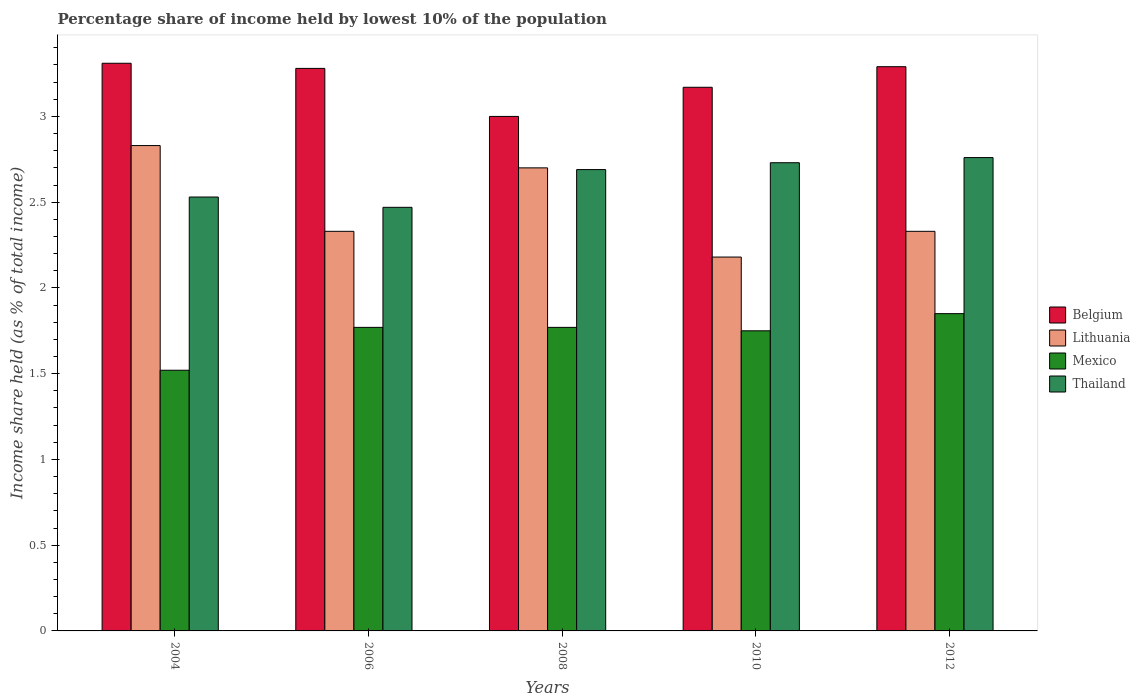Are the number of bars per tick equal to the number of legend labels?
Offer a terse response. Yes. How many bars are there on the 1st tick from the right?
Offer a very short reply. 4. What is the percentage share of income held by lowest 10% of the population in Mexico in 2004?
Ensure brevity in your answer.  1.52. Across all years, what is the maximum percentage share of income held by lowest 10% of the population in Lithuania?
Your response must be concise. 2.83. Across all years, what is the minimum percentage share of income held by lowest 10% of the population in Belgium?
Your response must be concise. 3. In which year was the percentage share of income held by lowest 10% of the population in Mexico maximum?
Make the answer very short. 2012. In which year was the percentage share of income held by lowest 10% of the population in Thailand minimum?
Make the answer very short. 2006. What is the total percentage share of income held by lowest 10% of the population in Belgium in the graph?
Your answer should be compact. 16.05. What is the difference between the percentage share of income held by lowest 10% of the population in Lithuania in 2010 and the percentage share of income held by lowest 10% of the population in Mexico in 2004?
Make the answer very short. 0.66. What is the average percentage share of income held by lowest 10% of the population in Belgium per year?
Keep it short and to the point. 3.21. In the year 2008, what is the difference between the percentage share of income held by lowest 10% of the population in Mexico and percentage share of income held by lowest 10% of the population in Lithuania?
Provide a succinct answer. -0.93. What is the ratio of the percentage share of income held by lowest 10% of the population in Mexico in 2004 to that in 2010?
Keep it short and to the point. 0.87. Is the percentage share of income held by lowest 10% of the population in Thailand in 2008 less than that in 2012?
Offer a very short reply. Yes. Is the difference between the percentage share of income held by lowest 10% of the population in Mexico in 2010 and 2012 greater than the difference between the percentage share of income held by lowest 10% of the population in Lithuania in 2010 and 2012?
Make the answer very short. Yes. What is the difference between the highest and the second highest percentage share of income held by lowest 10% of the population in Lithuania?
Provide a short and direct response. 0.13. What is the difference between the highest and the lowest percentage share of income held by lowest 10% of the population in Lithuania?
Make the answer very short. 0.65. What does the 4th bar from the left in 2006 represents?
Give a very brief answer. Thailand. What does the 1st bar from the right in 2012 represents?
Provide a succinct answer. Thailand. How many bars are there?
Offer a very short reply. 20. What is the difference between two consecutive major ticks on the Y-axis?
Provide a succinct answer. 0.5. Does the graph contain grids?
Keep it short and to the point. No. How many legend labels are there?
Offer a very short reply. 4. How are the legend labels stacked?
Give a very brief answer. Vertical. What is the title of the graph?
Give a very brief answer. Percentage share of income held by lowest 10% of the population. Does "Afghanistan" appear as one of the legend labels in the graph?
Your answer should be very brief. No. What is the label or title of the Y-axis?
Give a very brief answer. Income share held (as % of total income). What is the Income share held (as % of total income) of Belgium in 2004?
Ensure brevity in your answer.  3.31. What is the Income share held (as % of total income) in Lithuania in 2004?
Offer a very short reply. 2.83. What is the Income share held (as % of total income) in Mexico in 2004?
Ensure brevity in your answer.  1.52. What is the Income share held (as % of total income) of Thailand in 2004?
Ensure brevity in your answer.  2.53. What is the Income share held (as % of total income) in Belgium in 2006?
Provide a short and direct response. 3.28. What is the Income share held (as % of total income) of Lithuania in 2006?
Offer a very short reply. 2.33. What is the Income share held (as % of total income) of Mexico in 2006?
Offer a terse response. 1.77. What is the Income share held (as % of total income) in Thailand in 2006?
Provide a succinct answer. 2.47. What is the Income share held (as % of total income) of Mexico in 2008?
Offer a terse response. 1.77. What is the Income share held (as % of total income) in Thailand in 2008?
Provide a short and direct response. 2.69. What is the Income share held (as % of total income) of Belgium in 2010?
Provide a short and direct response. 3.17. What is the Income share held (as % of total income) of Lithuania in 2010?
Provide a short and direct response. 2.18. What is the Income share held (as % of total income) of Thailand in 2010?
Offer a very short reply. 2.73. What is the Income share held (as % of total income) of Belgium in 2012?
Offer a terse response. 3.29. What is the Income share held (as % of total income) of Lithuania in 2012?
Your answer should be very brief. 2.33. What is the Income share held (as % of total income) in Mexico in 2012?
Your answer should be compact. 1.85. What is the Income share held (as % of total income) in Thailand in 2012?
Offer a terse response. 2.76. Across all years, what is the maximum Income share held (as % of total income) in Belgium?
Ensure brevity in your answer.  3.31. Across all years, what is the maximum Income share held (as % of total income) of Lithuania?
Your response must be concise. 2.83. Across all years, what is the maximum Income share held (as % of total income) in Mexico?
Give a very brief answer. 1.85. Across all years, what is the maximum Income share held (as % of total income) in Thailand?
Your answer should be compact. 2.76. Across all years, what is the minimum Income share held (as % of total income) of Belgium?
Offer a very short reply. 3. Across all years, what is the minimum Income share held (as % of total income) of Lithuania?
Provide a short and direct response. 2.18. Across all years, what is the minimum Income share held (as % of total income) in Mexico?
Ensure brevity in your answer.  1.52. Across all years, what is the minimum Income share held (as % of total income) in Thailand?
Keep it short and to the point. 2.47. What is the total Income share held (as % of total income) in Belgium in the graph?
Keep it short and to the point. 16.05. What is the total Income share held (as % of total income) in Lithuania in the graph?
Make the answer very short. 12.37. What is the total Income share held (as % of total income) in Mexico in the graph?
Your answer should be very brief. 8.66. What is the total Income share held (as % of total income) in Thailand in the graph?
Provide a succinct answer. 13.18. What is the difference between the Income share held (as % of total income) of Lithuania in 2004 and that in 2006?
Give a very brief answer. 0.5. What is the difference between the Income share held (as % of total income) of Mexico in 2004 and that in 2006?
Give a very brief answer. -0.25. What is the difference between the Income share held (as % of total income) of Thailand in 2004 and that in 2006?
Provide a short and direct response. 0.06. What is the difference between the Income share held (as % of total income) in Belgium in 2004 and that in 2008?
Your answer should be compact. 0.31. What is the difference between the Income share held (as % of total income) in Lithuania in 2004 and that in 2008?
Keep it short and to the point. 0.13. What is the difference between the Income share held (as % of total income) in Mexico in 2004 and that in 2008?
Provide a short and direct response. -0.25. What is the difference between the Income share held (as % of total income) in Thailand in 2004 and that in 2008?
Offer a very short reply. -0.16. What is the difference between the Income share held (as % of total income) of Belgium in 2004 and that in 2010?
Your answer should be compact. 0.14. What is the difference between the Income share held (as % of total income) in Lithuania in 2004 and that in 2010?
Your answer should be compact. 0.65. What is the difference between the Income share held (as % of total income) in Mexico in 2004 and that in 2010?
Provide a succinct answer. -0.23. What is the difference between the Income share held (as % of total income) in Thailand in 2004 and that in 2010?
Your response must be concise. -0.2. What is the difference between the Income share held (as % of total income) of Lithuania in 2004 and that in 2012?
Your response must be concise. 0.5. What is the difference between the Income share held (as % of total income) of Mexico in 2004 and that in 2012?
Offer a terse response. -0.33. What is the difference between the Income share held (as % of total income) of Thailand in 2004 and that in 2012?
Offer a terse response. -0.23. What is the difference between the Income share held (as % of total income) of Belgium in 2006 and that in 2008?
Offer a very short reply. 0.28. What is the difference between the Income share held (as % of total income) of Lithuania in 2006 and that in 2008?
Your answer should be very brief. -0.37. What is the difference between the Income share held (as % of total income) in Thailand in 2006 and that in 2008?
Provide a succinct answer. -0.22. What is the difference between the Income share held (as % of total income) in Belgium in 2006 and that in 2010?
Offer a very short reply. 0.11. What is the difference between the Income share held (as % of total income) in Thailand in 2006 and that in 2010?
Offer a very short reply. -0.26. What is the difference between the Income share held (as % of total income) in Belgium in 2006 and that in 2012?
Ensure brevity in your answer.  -0.01. What is the difference between the Income share held (as % of total income) of Lithuania in 2006 and that in 2012?
Offer a very short reply. 0. What is the difference between the Income share held (as % of total income) in Mexico in 2006 and that in 2012?
Ensure brevity in your answer.  -0.08. What is the difference between the Income share held (as % of total income) in Thailand in 2006 and that in 2012?
Your response must be concise. -0.29. What is the difference between the Income share held (as % of total income) of Belgium in 2008 and that in 2010?
Your answer should be compact. -0.17. What is the difference between the Income share held (as % of total income) of Lithuania in 2008 and that in 2010?
Your answer should be compact. 0.52. What is the difference between the Income share held (as % of total income) in Thailand in 2008 and that in 2010?
Your answer should be very brief. -0.04. What is the difference between the Income share held (as % of total income) in Belgium in 2008 and that in 2012?
Ensure brevity in your answer.  -0.29. What is the difference between the Income share held (as % of total income) in Lithuania in 2008 and that in 2012?
Provide a short and direct response. 0.37. What is the difference between the Income share held (as % of total income) in Mexico in 2008 and that in 2012?
Your response must be concise. -0.08. What is the difference between the Income share held (as % of total income) of Thailand in 2008 and that in 2012?
Provide a succinct answer. -0.07. What is the difference between the Income share held (as % of total income) in Belgium in 2010 and that in 2012?
Your answer should be compact. -0.12. What is the difference between the Income share held (as % of total income) in Mexico in 2010 and that in 2012?
Offer a terse response. -0.1. What is the difference between the Income share held (as % of total income) in Thailand in 2010 and that in 2012?
Make the answer very short. -0.03. What is the difference between the Income share held (as % of total income) in Belgium in 2004 and the Income share held (as % of total income) in Mexico in 2006?
Provide a succinct answer. 1.54. What is the difference between the Income share held (as % of total income) of Belgium in 2004 and the Income share held (as % of total income) of Thailand in 2006?
Your answer should be compact. 0.84. What is the difference between the Income share held (as % of total income) of Lithuania in 2004 and the Income share held (as % of total income) of Mexico in 2006?
Ensure brevity in your answer.  1.06. What is the difference between the Income share held (as % of total income) in Lithuania in 2004 and the Income share held (as % of total income) in Thailand in 2006?
Keep it short and to the point. 0.36. What is the difference between the Income share held (as % of total income) in Mexico in 2004 and the Income share held (as % of total income) in Thailand in 2006?
Make the answer very short. -0.95. What is the difference between the Income share held (as % of total income) in Belgium in 2004 and the Income share held (as % of total income) in Lithuania in 2008?
Provide a succinct answer. 0.61. What is the difference between the Income share held (as % of total income) of Belgium in 2004 and the Income share held (as % of total income) of Mexico in 2008?
Offer a terse response. 1.54. What is the difference between the Income share held (as % of total income) in Belgium in 2004 and the Income share held (as % of total income) in Thailand in 2008?
Make the answer very short. 0.62. What is the difference between the Income share held (as % of total income) of Lithuania in 2004 and the Income share held (as % of total income) of Mexico in 2008?
Your response must be concise. 1.06. What is the difference between the Income share held (as % of total income) of Lithuania in 2004 and the Income share held (as % of total income) of Thailand in 2008?
Provide a short and direct response. 0.14. What is the difference between the Income share held (as % of total income) in Mexico in 2004 and the Income share held (as % of total income) in Thailand in 2008?
Your answer should be very brief. -1.17. What is the difference between the Income share held (as % of total income) in Belgium in 2004 and the Income share held (as % of total income) in Lithuania in 2010?
Keep it short and to the point. 1.13. What is the difference between the Income share held (as % of total income) of Belgium in 2004 and the Income share held (as % of total income) of Mexico in 2010?
Provide a succinct answer. 1.56. What is the difference between the Income share held (as % of total income) of Belgium in 2004 and the Income share held (as % of total income) of Thailand in 2010?
Offer a very short reply. 0.58. What is the difference between the Income share held (as % of total income) of Lithuania in 2004 and the Income share held (as % of total income) of Thailand in 2010?
Give a very brief answer. 0.1. What is the difference between the Income share held (as % of total income) of Mexico in 2004 and the Income share held (as % of total income) of Thailand in 2010?
Your answer should be very brief. -1.21. What is the difference between the Income share held (as % of total income) in Belgium in 2004 and the Income share held (as % of total income) in Lithuania in 2012?
Keep it short and to the point. 0.98. What is the difference between the Income share held (as % of total income) in Belgium in 2004 and the Income share held (as % of total income) in Mexico in 2012?
Make the answer very short. 1.46. What is the difference between the Income share held (as % of total income) in Belgium in 2004 and the Income share held (as % of total income) in Thailand in 2012?
Your response must be concise. 0.55. What is the difference between the Income share held (as % of total income) of Lithuania in 2004 and the Income share held (as % of total income) of Thailand in 2012?
Offer a very short reply. 0.07. What is the difference between the Income share held (as % of total income) in Mexico in 2004 and the Income share held (as % of total income) in Thailand in 2012?
Ensure brevity in your answer.  -1.24. What is the difference between the Income share held (as % of total income) of Belgium in 2006 and the Income share held (as % of total income) of Lithuania in 2008?
Provide a succinct answer. 0.58. What is the difference between the Income share held (as % of total income) of Belgium in 2006 and the Income share held (as % of total income) of Mexico in 2008?
Provide a succinct answer. 1.51. What is the difference between the Income share held (as % of total income) of Belgium in 2006 and the Income share held (as % of total income) of Thailand in 2008?
Ensure brevity in your answer.  0.59. What is the difference between the Income share held (as % of total income) of Lithuania in 2006 and the Income share held (as % of total income) of Mexico in 2008?
Offer a very short reply. 0.56. What is the difference between the Income share held (as % of total income) of Lithuania in 2006 and the Income share held (as % of total income) of Thailand in 2008?
Ensure brevity in your answer.  -0.36. What is the difference between the Income share held (as % of total income) in Mexico in 2006 and the Income share held (as % of total income) in Thailand in 2008?
Your answer should be very brief. -0.92. What is the difference between the Income share held (as % of total income) in Belgium in 2006 and the Income share held (as % of total income) in Lithuania in 2010?
Give a very brief answer. 1.1. What is the difference between the Income share held (as % of total income) of Belgium in 2006 and the Income share held (as % of total income) of Mexico in 2010?
Your answer should be very brief. 1.53. What is the difference between the Income share held (as % of total income) of Belgium in 2006 and the Income share held (as % of total income) of Thailand in 2010?
Provide a succinct answer. 0.55. What is the difference between the Income share held (as % of total income) in Lithuania in 2006 and the Income share held (as % of total income) in Mexico in 2010?
Offer a very short reply. 0.58. What is the difference between the Income share held (as % of total income) of Lithuania in 2006 and the Income share held (as % of total income) of Thailand in 2010?
Keep it short and to the point. -0.4. What is the difference between the Income share held (as % of total income) in Mexico in 2006 and the Income share held (as % of total income) in Thailand in 2010?
Keep it short and to the point. -0.96. What is the difference between the Income share held (as % of total income) in Belgium in 2006 and the Income share held (as % of total income) in Lithuania in 2012?
Offer a terse response. 0.95. What is the difference between the Income share held (as % of total income) of Belgium in 2006 and the Income share held (as % of total income) of Mexico in 2012?
Keep it short and to the point. 1.43. What is the difference between the Income share held (as % of total income) of Belgium in 2006 and the Income share held (as % of total income) of Thailand in 2012?
Your response must be concise. 0.52. What is the difference between the Income share held (as % of total income) in Lithuania in 2006 and the Income share held (as % of total income) in Mexico in 2012?
Provide a succinct answer. 0.48. What is the difference between the Income share held (as % of total income) of Lithuania in 2006 and the Income share held (as % of total income) of Thailand in 2012?
Provide a succinct answer. -0.43. What is the difference between the Income share held (as % of total income) of Mexico in 2006 and the Income share held (as % of total income) of Thailand in 2012?
Offer a very short reply. -0.99. What is the difference between the Income share held (as % of total income) in Belgium in 2008 and the Income share held (as % of total income) in Lithuania in 2010?
Offer a terse response. 0.82. What is the difference between the Income share held (as % of total income) in Belgium in 2008 and the Income share held (as % of total income) in Thailand in 2010?
Your answer should be very brief. 0.27. What is the difference between the Income share held (as % of total income) of Lithuania in 2008 and the Income share held (as % of total income) of Thailand in 2010?
Your answer should be very brief. -0.03. What is the difference between the Income share held (as % of total income) of Mexico in 2008 and the Income share held (as % of total income) of Thailand in 2010?
Make the answer very short. -0.96. What is the difference between the Income share held (as % of total income) in Belgium in 2008 and the Income share held (as % of total income) in Lithuania in 2012?
Ensure brevity in your answer.  0.67. What is the difference between the Income share held (as % of total income) of Belgium in 2008 and the Income share held (as % of total income) of Mexico in 2012?
Make the answer very short. 1.15. What is the difference between the Income share held (as % of total income) in Belgium in 2008 and the Income share held (as % of total income) in Thailand in 2012?
Your answer should be compact. 0.24. What is the difference between the Income share held (as % of total income) of Lithuania in 2008 and the Income share held (as % of total income) of Thailand in 2012?
Your answer should be compact. -0.06. What is the difference between the Income share held (as % of total income) in Mexico in 2008 and the Income share held (as % of total income) in Thailand in 2012?
Ensure brevity in your answer.  -0.99. What is the difference between the Income share held (as % of total income) in Belgium in 2010 and the Income share held (as % of total income) in Lithuania in 2012?
Offer a very short reply. 0.84. What is the difference between the Income share held (as % of total income) in Belgium in 2010 and the Income share held (as % of total income) in Mexico in 2012?
Ensure brevity in your answer.  1.32. What is the difference between the Income share held (as % of total income) in Belgium in 2010 and the Income share held (as % of total income) in Thailand in 2012?
Keep it short and to the point. 0.41. What is the difference between the Income share held (as % of total income) of Lithuania in 2010 and the Income share held (as % of total income) of Mexico in 2012?
Offer a terse response. 0.33. What is the difference between the Income share held (as % of total income) in Lithuania in 2010 and the Income share held (as % of total income) in Thailand in 2012?
Offer a very short reply. -0.58. What is the difference between the Income share held (as % of total income) in Mexico in 2010 and the Income share held (as % of total income) in Thailand in 2012?
Offer a terse response. -1.01. What is the average Income share held (as % of total income) of Belgium per year?
Ensure brevity in your answer.  3.21. What is the average Income share held (as % of total income) in Lithuania per year?
Your response must be concise. 2.47. What is the average Income share held (as % of total income) in Mexico per year?
Your response must be concise. 1.73. What is the average Income share held (as % of total income) in Thailand per year?
Your answer should be very brief. 2.64. In the year 2004, what is the difference between the Income share held (as % of total income) of Belgium and Income share held (as % of total income) of Lithuania?
Your response must be concise. 0.48. In the year 2004, what is the difference between the Income share held (as % of total income) of Belgium and Income share held (as % of total income) of Mexico?
Your response must be concise. 1.79. In the year 2004, what is the difference between the Income share held (as % of total income) of Belgium and Income share held (as % of total income) of Thailand?
Offer a terse response. 0.78. In the year 2004, what is the difference between the Income share held (as % of total income) in Lithuania and Income share held (as % of total income) in Mexico?
Provide a short and direct response. 1.31. In the year 2004, what is the difference between the Income share held (as % of total income) of Lithuania and Income share held (as % of total income) of Thailand?
Your response must be concise. 0.3. In the year 2004, what is the difference between the Income share held (as % of total income) in Mexico and Income share held (as % of total income) in Thailand?
Provide a short and direct response. -1.01. In the year 2006, what is the difference between the Income share held (as % of total income) in Belgium and Income share held (as % of total income) in Mexico?
Make the answer very short. 1.51. In the year 2006, what is the difference between the Income share held (as % of total income) in Belgium and Income share held (as % of total income) in Thailand?
Give a very brief answer. 0.81. In the year 2006, what is the difference between the Income share held (as % of total income) of Lithuania and Income share held (as % of total income) of Mexico?
Ensure brevity in your answer.  0.56. In the year 2006, what is the difference between the Income share held (as % of total income) of Lithuania and Income share held (as % of total income) of Thailand?
Provide a succinct answer. -0.14. In the year 2008, what is the difference between the Income share held (as % of total income) in Belgium and Income share held (as % of total income) in Lithuania?
Ensure brevity in your answer.  0.3. In the year 2008, what is the difference between the Income share held (as % of total income) of Belgium and Income share held (as % of total income) of Mexico?
Make the answer very short. 1.23. In the year 2008, what is the difference between the Income share held (as % of total income) in Belgium and Income share held (as % of total income) in Thailand?
Offer a terse response. 0.31. In the year 2008, what is the difference between the Income share held (as % of total income) of Lithuania and Income share held (as % of total income) of Thailand?
Your answer should be very brief. 0.01. In the year 2008, what is the difference between the Income share held (as % of total income) of Mexico and Income share held (as % of total income) of Thailand?
Your response must be concise. -0.92. In the year 2010, what is the difference between the Income share held (as % of total income) of Belgium and Income share held (as % of total income) of Mexico?
Give a very brief answer. 1.42. In the year 2010, what is the difference between the Income share held (as % of total income) of Belgium and Income share held (as % of total income) of Thailand?
Make the answer very short. 0.44. In the year 2010, what is the difference between the Income share held (as % of total income) in Lithuania and Income share held (as % of total income) in Mexico?
Your answer should be very brief. 0.43. In the year 2010, what is the difference between the Income share held (as % of total income) of Lithuania and Income share held (as % of total income) of Thailand?
Ensure brevity in your answer.  -0.55. In the year 2010, what is the difference between the Income share held (as % of total income) in Mexico and Income share held (as % of total income) in Thailand?
Ensure brevity in your answer.  -0.98. In the year 2012, what is the difference between the Income share held (as % of total income) of Belgium and Income share held (as % of total income) of Mexico?
Make the answer very short. 1.44. In the year 2012, what is the difference between the Income share held (as % of total income) of Belgium and Income share held (as % of total income) of Thailand?
Make the answer very short. 0.53. In the year 2012, what is the difference between the Income share held (as % of total income) in Lithuania and Income share held (as % of total income) in Mexico?
Your answer should be compact. 0.48. In the year 2012, what is the difference between the Income share held (as % of total income) of Lithuania and Income share held (as % of total income) of Thailand?
Offer a very short reply. -0.43. In the year 2012, what is the difference between the Income share held (as % of total income) in Mexico and Income share held (as % of total income) in Thailand?
Offer a terse response. -0.91. What is the ratio of the Income share held (as % of total income) of Belgium in 2004 to that in 2006?
Your answer should be very brief. 1.01. What is the ratio of the Income share held (as % of total income) of Lithuania in 2004 to that in 2006?
Make the answer very short. 1.21. What is the ratio of the Income share held (as % of total income) of Mexico in 2004 to that in 2006?
Keep it short and to the point. 0.86. What is the ratio of the Income share held (as % of total income) of Thailand in 2004 to that in 2006?
Give a very brief answer. 1.02. What is the ratio of the Income share held (as % of total income) in Belgium in 2004 to that in 2008?
Your response must be concise. 1.1. What is the ratio of the Income share held (as % of total income) of Lithuania in 2004 to that in 2008?
Offer a very short reply. 1.05. What is the ratio of the Income share held (as % of total income) in Mexico in 2004 to that in 2008?
Your answer should be compact. 0.86. What is the ratio of the Income share held (as % of total income) in Thailand in 2004 to that in 2008?
Keep it short and to the point. 0.94. What is the ratio of the Income share held (as % of total income) in Belgium in 2004 to that in 2010?
Your answer should be very brief. 1.04. What is the ratio of the Income share held (as % of total income) of Lithuania in 2004 to that in 2010?
Offer a terse response. 1.3. What is the ratio of the Income share held (as % of total income) of Mexico in 2004 to that in 2010?
Your answer should be compact. 0.87. What is the ratio of the Income share held (as % of total income) in Thailand in 2004 to that in 2010?
Offer a terse response. 0.93. What is the ratio of the Income share held (as % of total income) in Belgium in 2004 to that in 2012?
Give a very brief answer. 1.01. What is the ratio of the Income share held (as % of total income) in Lithuania in 2004 to that in 2012?
Provide a succinct answer. 1.21. What is the ratio of the Income share held (as % of total income) of Mexico in 2004 to that in 2012?
Offer a terse response. 0.82. What is the ratio of the Income share held (as % of total income) in Thailand in 2004 to that in 2012?
Make the answer very short. 0.92. What is the ratio of the Income share held (as % of total income) of Belgium in 2006 to that in 2008?
Give a very brief answer. 1.09. What is the ratio of the Income share held (as % of total income) in Lithuania in 2006 to that in 2008?
Your answer should be very brief. 0.86. What is the ratio of the Income share held (as % of total income) of Thailand in 2006 to that in 2008?
Your response must be concise. 0.92. What is the ratio of the Income share held (as % of total income) in Belgium in 2006 to that in 2010?
Ensure brevity in your answer.  1.03. What is the ratio of the Income share held (as % of total income) of Lithuania in 2006 to that in 2010?
Your answer should be compact. 1.07. What is the ratio of the Income share held (as % of total income) of Mexico in 2006 to that in 2010?
Your response must be concise. 1.01. What is the ratio of the Income share held (as % of total income) of Thailand in 2006 to that in 2010?
Make the answer very short. 0.9. What is the ratio of the Income share held (as % of total income) in Belgium in 2006 to that in 2012?
Provide a short and direct response. 1. What is the ratio of the Income share held (as % of total income) in Lithuania in 2006 to that in 2012?
Make the answer very short. 1. What is the ratio of the Income share held (as % of total income) of Mexico in 2006 to that in 2012?
Your answer should be very brief. 0.96. What is the ratio of the Income share held (as % of total income) of Thailand in 2006 to that in 2012?
Offer a very short reply. 0.89. What is the ratio of the Income share held (as % of total income) in Belgium in 2008 to that in 2010?
Give a very brief answer. 0.95. What is the ratio of the Income share held (as % of total income) of Lithuania in 2008 to that in 2010?
Provide a succinct answer. 1.24. What is the ratio of the Income share held (as % of total income) in Mexico in 2008 to that in 2010?
Provide a short and direct response. 1.01. What is the ratio of the Income share held (as % of total income) in Thailand in 2008 to that in 2010?
Ensure brevity in your answer.  0.99. What is the ratio of the Income share held (as % of total income) of Belgium in 2008 to that in 2012?
Make the answer very short. 0.91. What is the ratio of the Income share held (as % of total income) of Lithuania in 2008 to that in 2012?
Offer a terse response. 1.16. What is the ratio of the Income share held (as % of total income) of Mexico in 2008 to that in 2012?
Offer a very short reply. 0.96. What is the ratio of the Income share held (as % of total income) in Thailand in 2008 to that in 2012?
Give a very brief answer. 0.97. What is the ratio of the Income share held (as % of total income) in Belgium in 2010 to that in 2012?
Provide a short and direct response. 0.96. What is the ratio of the Income share held (as % of total income) of Lithuania in 2010 to that in 2012?
Your response must be concise. 0.94. What is the ratio of the Income share held (as % of total income) in Mexico in 2010 to that in 2012?
Your answer should be very brief. 0.95. What is the difference between the highest and the second highest Income share held (as % of total income) of Belgium?
Provide a short and direct response. 0.02. What is the difference between the highest and the second highest Income share held (as % of total income) in Lithuania?
Give a very brief answer. 0.13. What is the difference between the highest and the second highest Income share held (as % of total income) of Mexico?
Give a very brief answer. 0.08. What is the difference between the highest and the second highest Income share held (as % of total income) of Thailand?
Your response must be concise. 0.03. What is the difference between the highest and the lowest Income share held (as % of total income) of Belgium?
Provide a short and direct response. 0.31. What is the difference between the highest and the lowest Income share held (as % of total income) of Lithuania?
Your answer should be very brief. 0.65. What is the difference between the highest and the lowest Income share held (as % of total income) in Mexico?
Provide a succinct answer. 0.33. What is the difference between the highest and the lowest Income share held (as % of total income) in Thailand?
Make the answer very short. 0.29. 